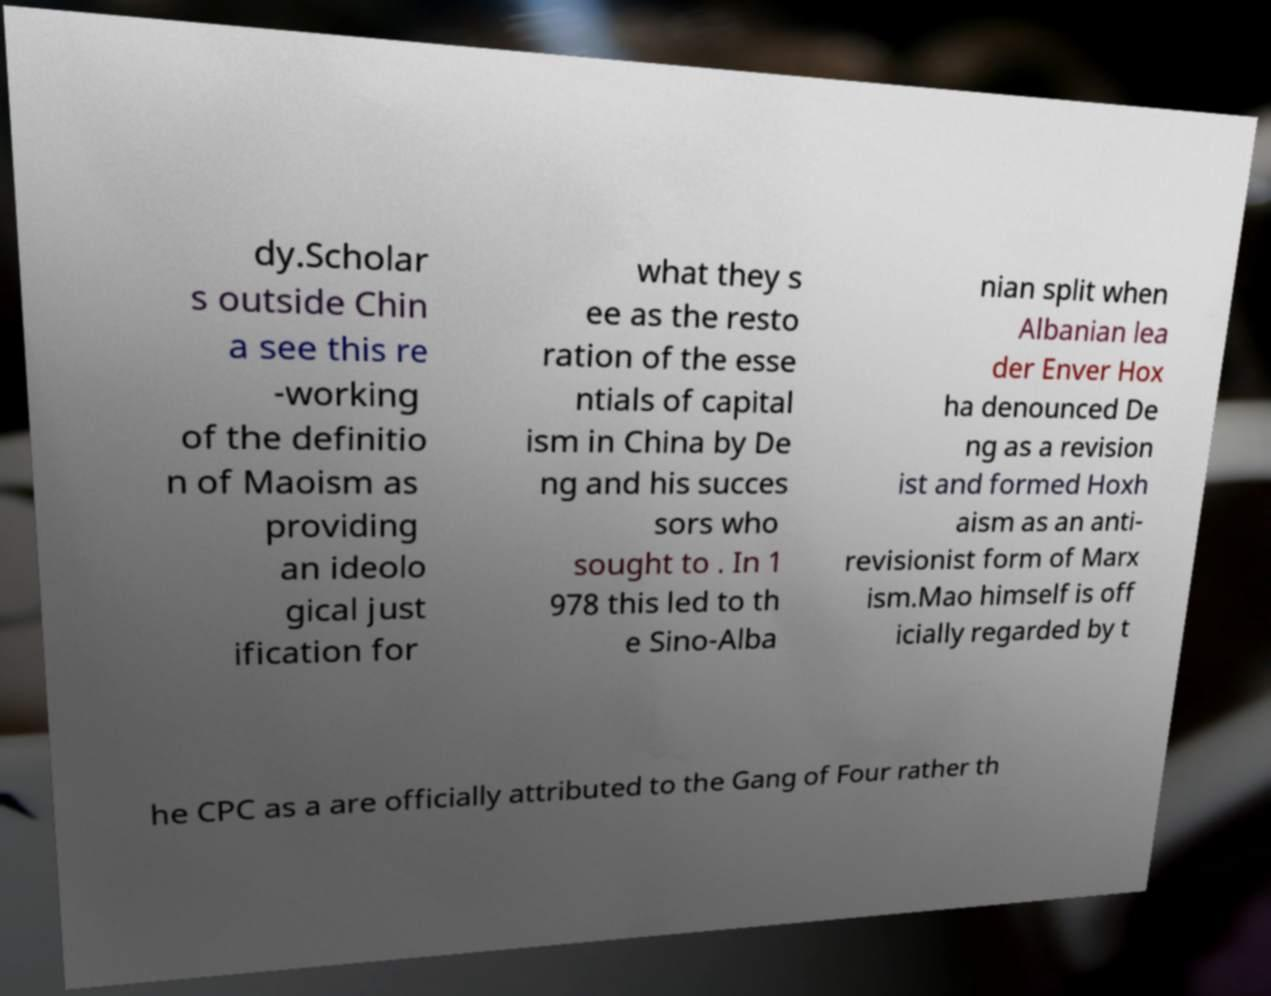Can you accurately transcribe the text from the provided image for me? dy.Scholar s outside Chin a see this re -working of the definitio n of Maoism as providing an ideolo gical just ification for what they s ee as the resto ration of the esse ntials of capital ism in China by De ng and his succes sors who sought to . In 1 978 this led to th e Sino-Alba nian split when Albanian lea der Enver Hox ha denounced De ng as a revision ist and formed Hoxh aism as an anti- revisionist form of Marx ism.Mao himself is off icially regarded by t he CPC as a are officially attributed to the Gang of Four rather th 